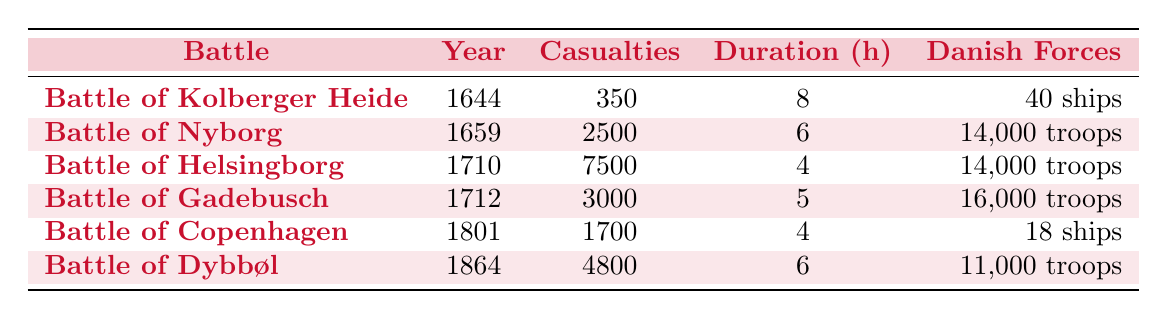What was the highest number of casualties in a single battle? The highest number of casualties is 7500, which occurred in the Battle of Helsingborg in 1710.
Answer: 7500 Which battle took place in 1659? The Battle of Nyborg took place in 1659 as indicated in the table.
Answer: Battle of Nyborg How many Danish troops were involved in the Battle of Gadebusch? The table shows that 16,000 Danish troops were involved in the Battle of Gadebusch in 1712.
Answer: 16,000 troops What is the average duration of the battles listed? The durations are 8, 6, 4, 5, 4, and 6 hours. The total duration is 33 hours for 6 battles, so the average is 33/6 = 5.5 hours.
Answer: 5.5 hours Did the Battle of Kolberger Heide have more or less than 400 casualties? The Battle of Kolberger Heide had 350 casualties, which is less than 400.
Answer: Less than How many more casualties did the Battle of Dybbøl have compared to the Battle of Copenhagen? The Battle of Dybbøl had 4800 casualties, while the Battle of Copenhagen had 1700. The difference is 4800 - 1700 = 3100.
Answer: 3100 casualties What was the total number of casualties in all listed battles? The total casualties are 350 + 2500 + 7500 + 3000 + 1700 + 4800 = 19550.
Answer: 19,550 How many ships were involved in the Battle of Copenhagen? In the Battle of Copenhagen, 18 Danish ships were involved.
Answer: 18 ships Which battle had the shortest duration? The battle with the shortest duration is the Battle of Helsingborg, lasting 4 hours.
Answer: Battle of Helsingborg What is the difference in the number of Danish troops between the Battle of Nyborg and the Battle of Gadebusch? The Battle of Nyborg had 14,000 troops, while the Battle of Gadebusch had 16,000 troops. The difference is 16,000 - 14,000 = 2000 troops.
Answer: 2000 troops Was the Battle of Kolberger Heide shorter than the Battle of Dybbøl? The Battle of Kolberger Heide lasted 8 hours, while the Battle of Dybbøl lasted 6 hours, so yes, it was longer.
Answer: No 